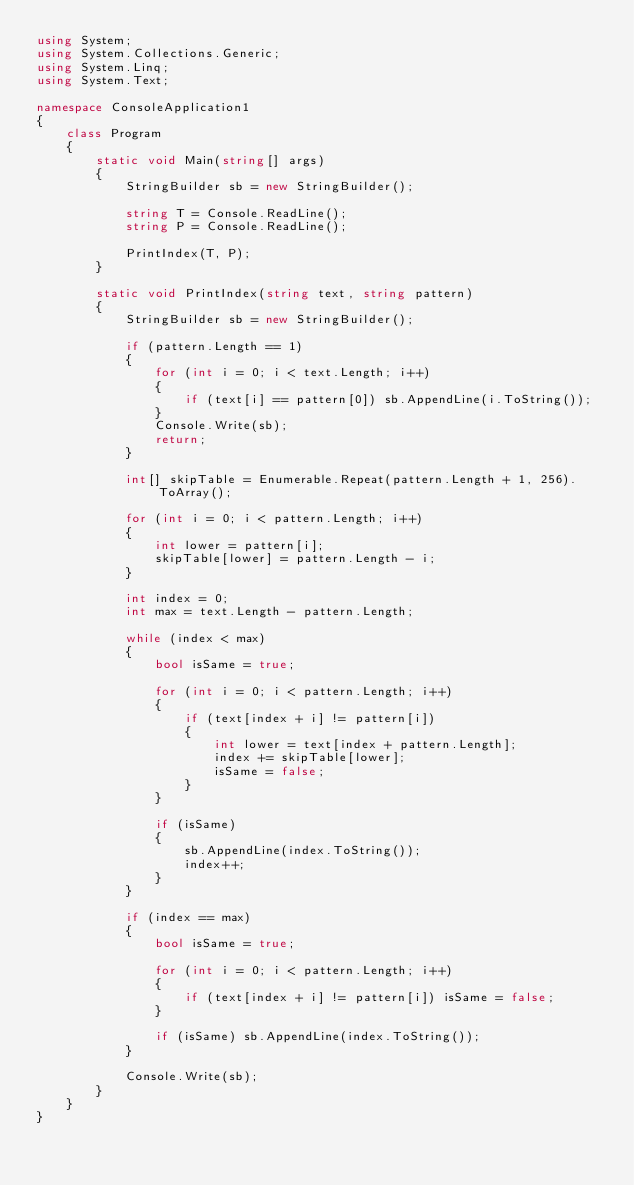Convert code to text. <code><loc_0><loc_0><loc_500><loc_500><_C#_>using System;
using System.Collections.Generic;
using System.Linq;
using System.Text;

namespace ConsoleApplication1
{
    class Program
    {
        static void Main(string[] args)
        {
            StringBuilder sb = new StringBuilder();

            string T = Console.ReadLine();
            string P = Console.ReadLine();

            PrintIndex(T, P);
        }

        static void PrintIndex(string text, string pattern)
        {
            StringBuilder sb = new StringBuilder();

            if (pattern.Length == 1)
            {
                for (int i = 0; i < text.Length; i++)
                {
                    if (text[i] == pattern[0]) sb.AppendLine(i.ToString());
                }
                Console.Write(sb);
                return;
            }

            int[] skipTable = Enumerable.Repeat(pattern.Length + 1, 256).ToArray();

            for (int i = 0; i < pattern.Length; i++)
            {
                int lower = pattern[i];
                skipTable[lower] = pattern.Length - i;
            }

            int index = 0;
            int max = text.Length - pattern.Length;

            while (index < max)
            {
                bool isSame = true;

                for (int i = 0; i < pattern.Length; i++)
                {
                    if (text[index + i] != pattern[i])
                    {
                        int lower = text[index + pattern.Length];
                        index += skipTable[lower];
                        isSame = false;
                    }
                }

                if (isSame)
                {
                    sb.AppendLine(index.ToString());
                    index++;
                }
            }

            if (index == max)
            {
                bool isSame = true;

                for (int i = 0; i < pattern.Length; i++)
                {
                    if (text[index + i] != pattern[i]) isSame = false;
                }

                if (isSame) sb.AppendLine(index.ToString());
            }

            Console.Write(sb);
        }
    }
}</code> 